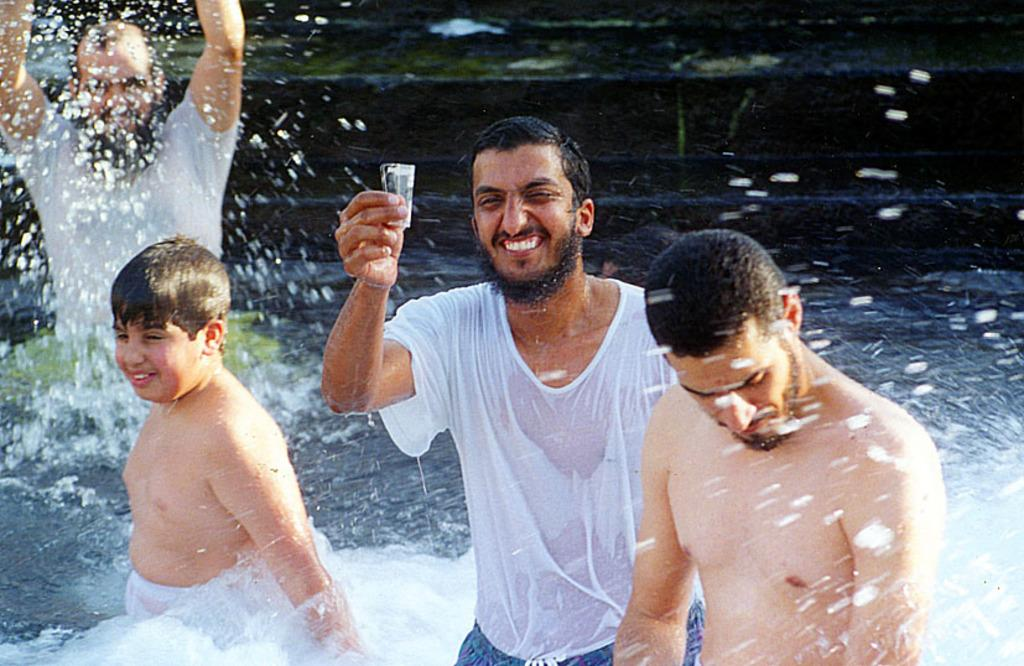What are the people in the image doing? The people in the image are in the water. Can you describe the man's action in the image? The man is holding an object. What type of plate is the man holding in the image? There is no plate present in the image; the man is holding an object, but it is not specified as a plate. What kind of paste is being used by the people in the water? There is no paste present in the image; the people are simply in the water. 